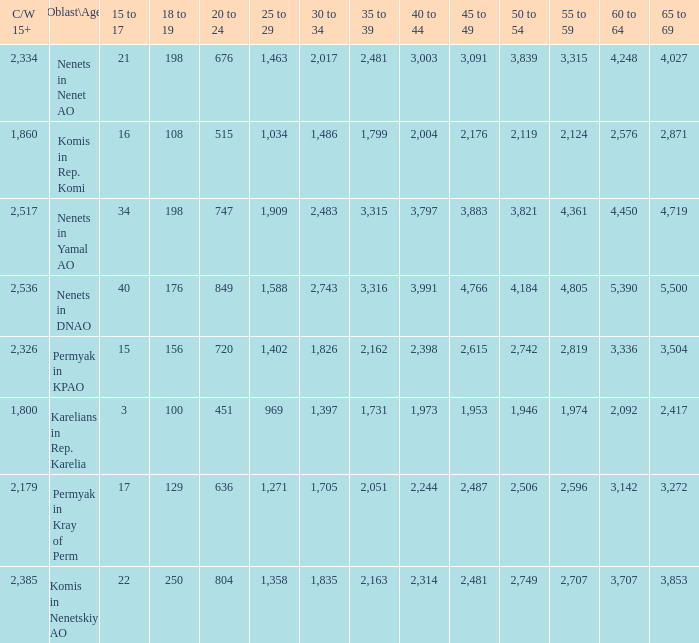What is the number of 40 to 44 when the 50 to 54 is less than 4,184, and the 15 to 17 is less than 3? 0.0. 